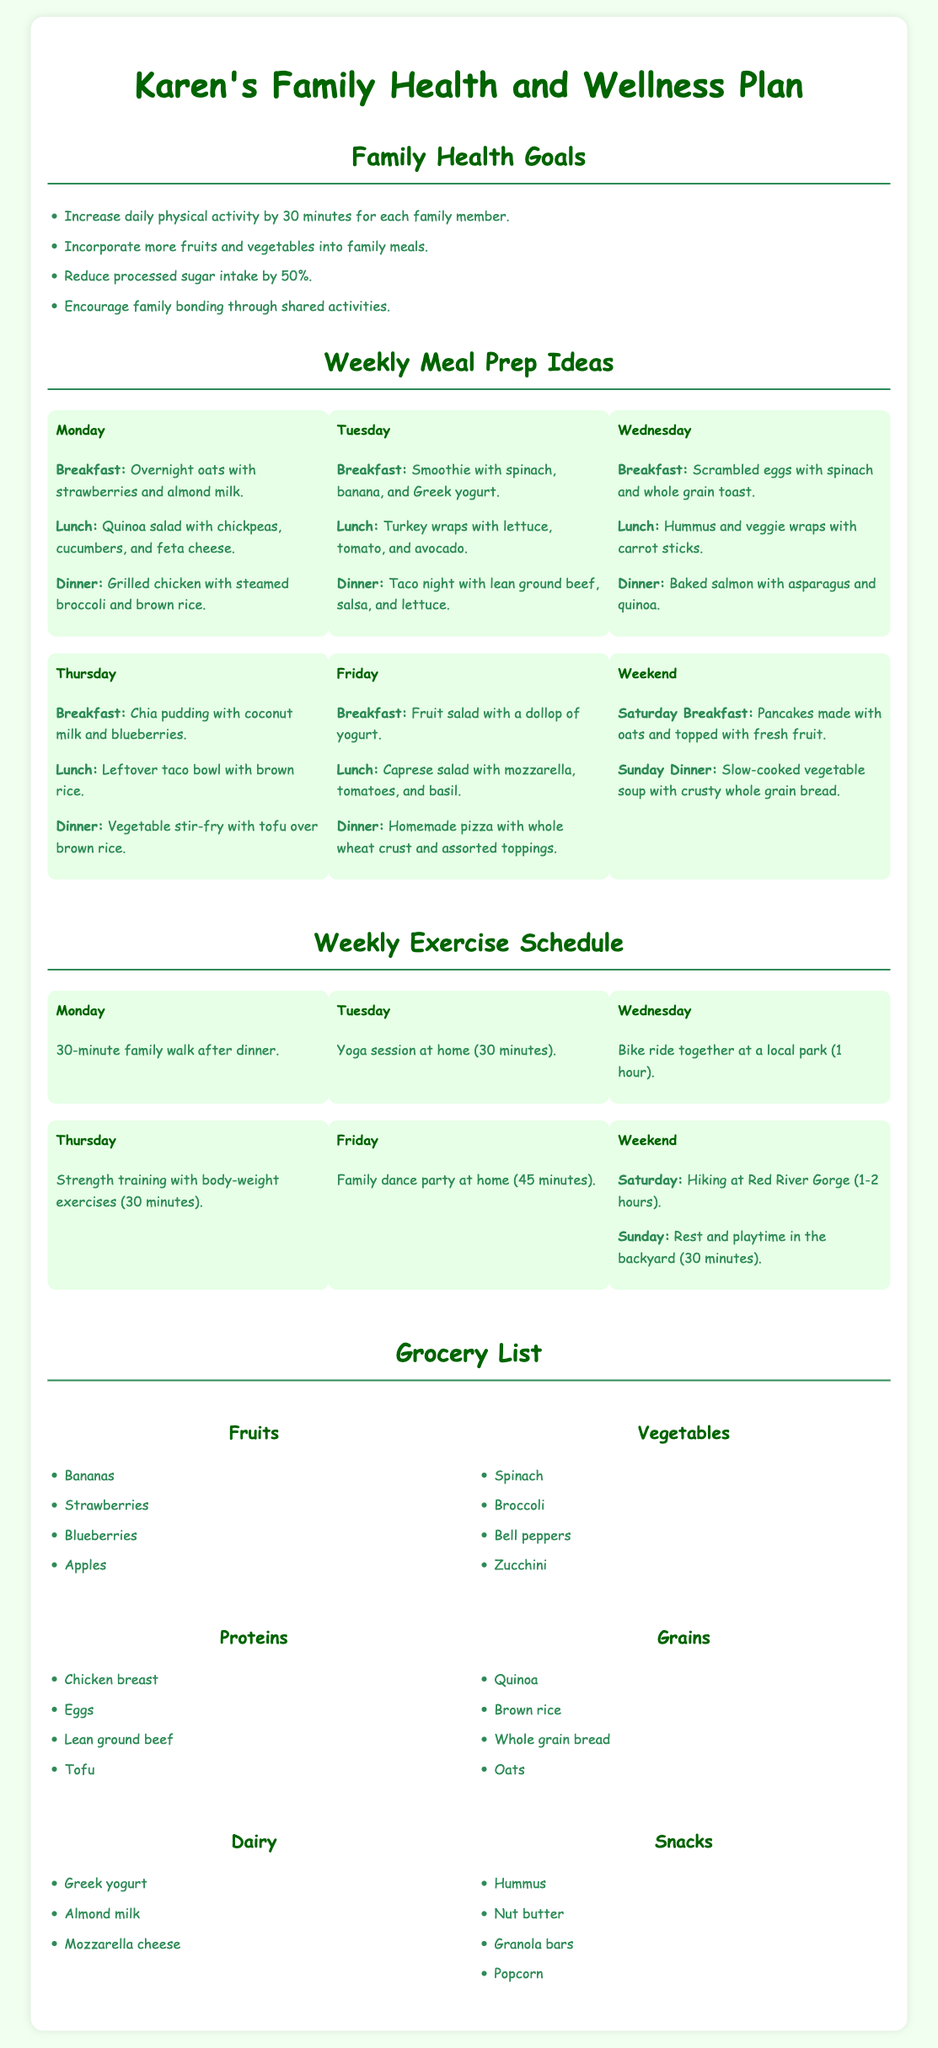What are the family health goals? The family health goals are listed in bullet points under the "Family Health Goals" section.
Answer: Increase daily physical activity by 30 minutes for each family member, Incorporate more fruits and vegetables into family meals, Reduce processed sugar intake by 50%, Encourage family bonding through shared activities What is Monday's dinner? The dinner for Monday is referenced in the "Weekly Meal Prep Ideas" section.
Answer: Grilled chicken with steamed broccoli and brown rice How long is the family walk on Monday? The exercise schedule specifies the duration for the family walk on Monday.
Answer: 30 minutes What grocery category includes quinoa? Quinoa is listed in the "Grains" category of the grocery list.
Answer: Grains Which day includes a family dance party? The "Weekly Exercise Schedule" indicates the day for the family dance party.
Answer: Friday What type of protein is mentioned for the meal prep? The document includes various protein sources in the "Proteins" grocery list.
Answer: Chicken breast, Eggs, Lean ground beef, Tofu 